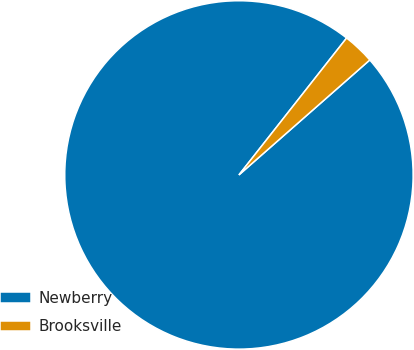Convert chart. <chart><loc_0><loc_0><loc_500><loc_500><pie_chart><fcel>Newberry<fcel>Brooksville<nl><fcel>97.08%<fcel>2.92%<nl></chart> 